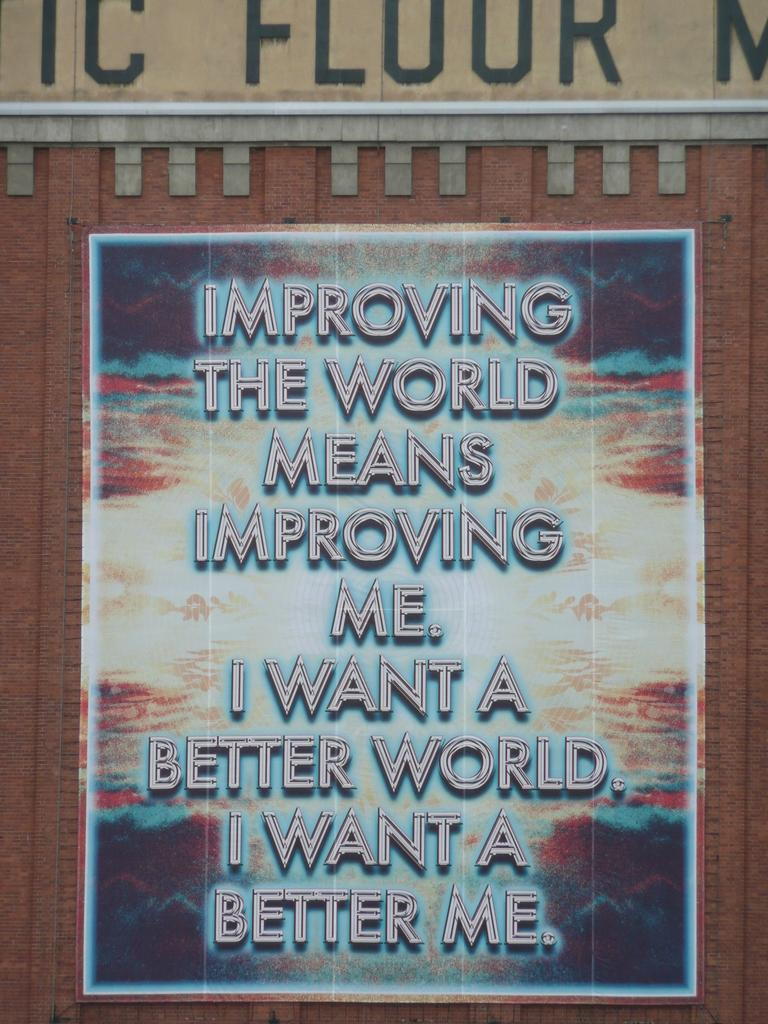<image>
Present a compact description of the photo's key features. A poster that reads improving the world means improving me. 